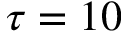Convert formula to latex. <formula><loc_0><loc_0><loc_500><loc_500>\tau = 1 0</formula> 